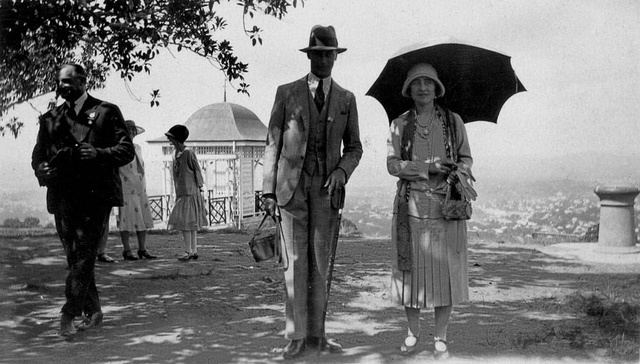Describe the objects in this image and their specific colors. I can see people in gray, black, darkgray, and lightgray tones, people in gray, black, darkgray, and lightgray tones, people in gray, black, darkgray, and lightgray tones, umbrella in gray, black, lightgray, and darkgray tones, and people in gray, black, darkgray, and lightgray tones in this image. 